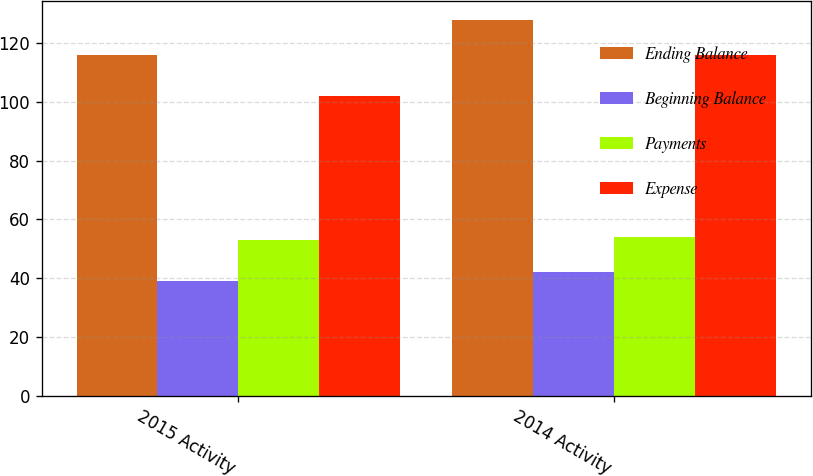Convert chart to OTSL. <chart><loc_0><loc_0><loc_500><loc_500><stacked_bar_chart><ecel><fcel>2015 Activity<fcel>2014 Activity<nl><fcel>Ending Balance<fcel>116<fcel>128<nl><fcel>Beginning Balance<fcel>39<fcel>42<nl><fcel>Payments<fcel>53<fcel>54<nl><fcel>Expense<fcel>102<fcel>116<nl></chart> 